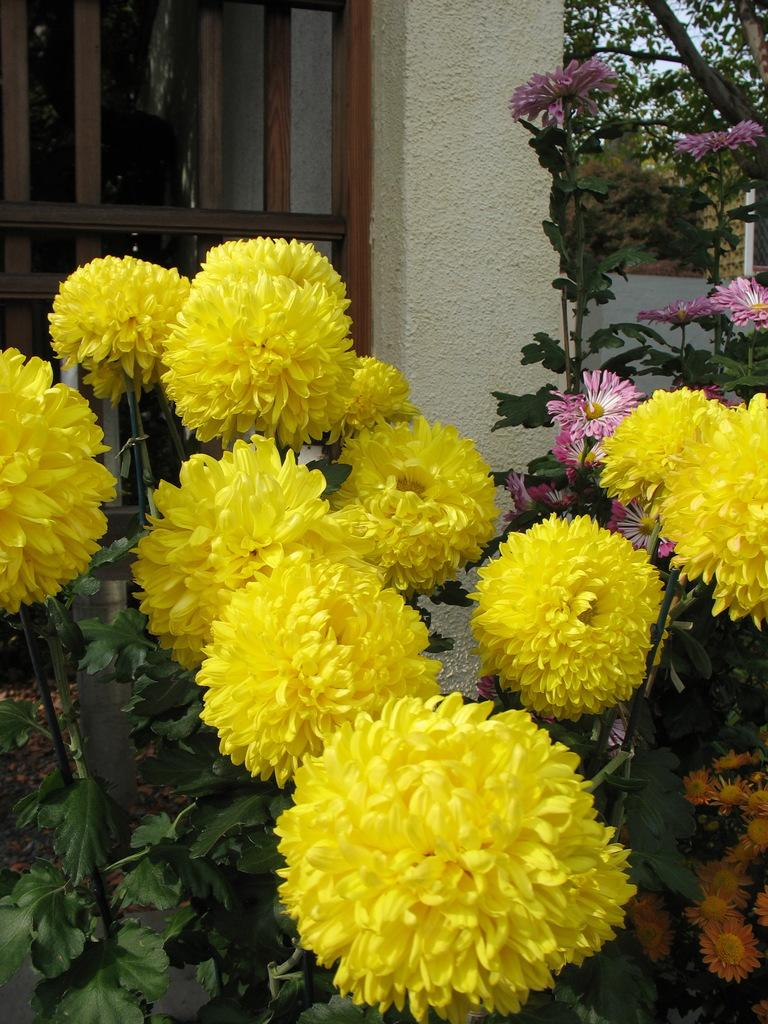What type of plant is in the image? The plant in the image has flowers on it. What colors are the flowers on the plant? The flowers are in yellow, orange, and pink colors. What can be seen on the wall in the image? There is a window on the wall in the image. What is visible outside the window? Trees are visible behind the window. How many screws are holding the light bulb in the image? There is no light bulb or screws present in the image. 